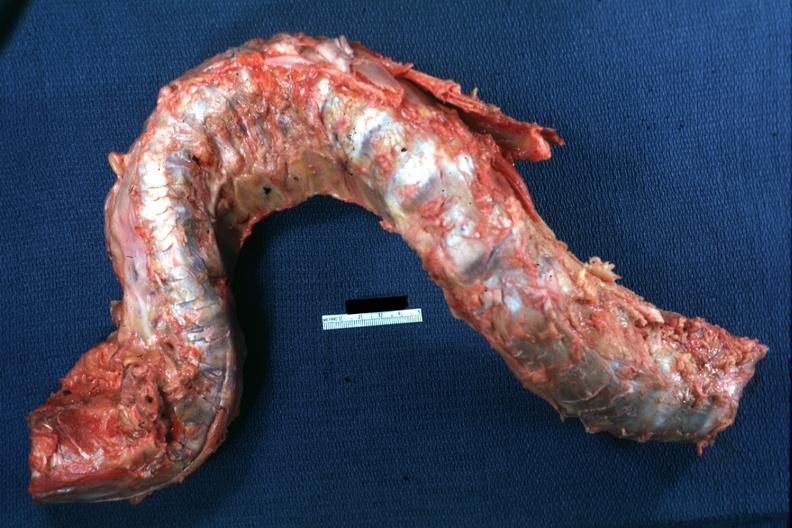does this image show excised spinal column grossly deformed?
Answer the question using a single word or phrase. Yes 